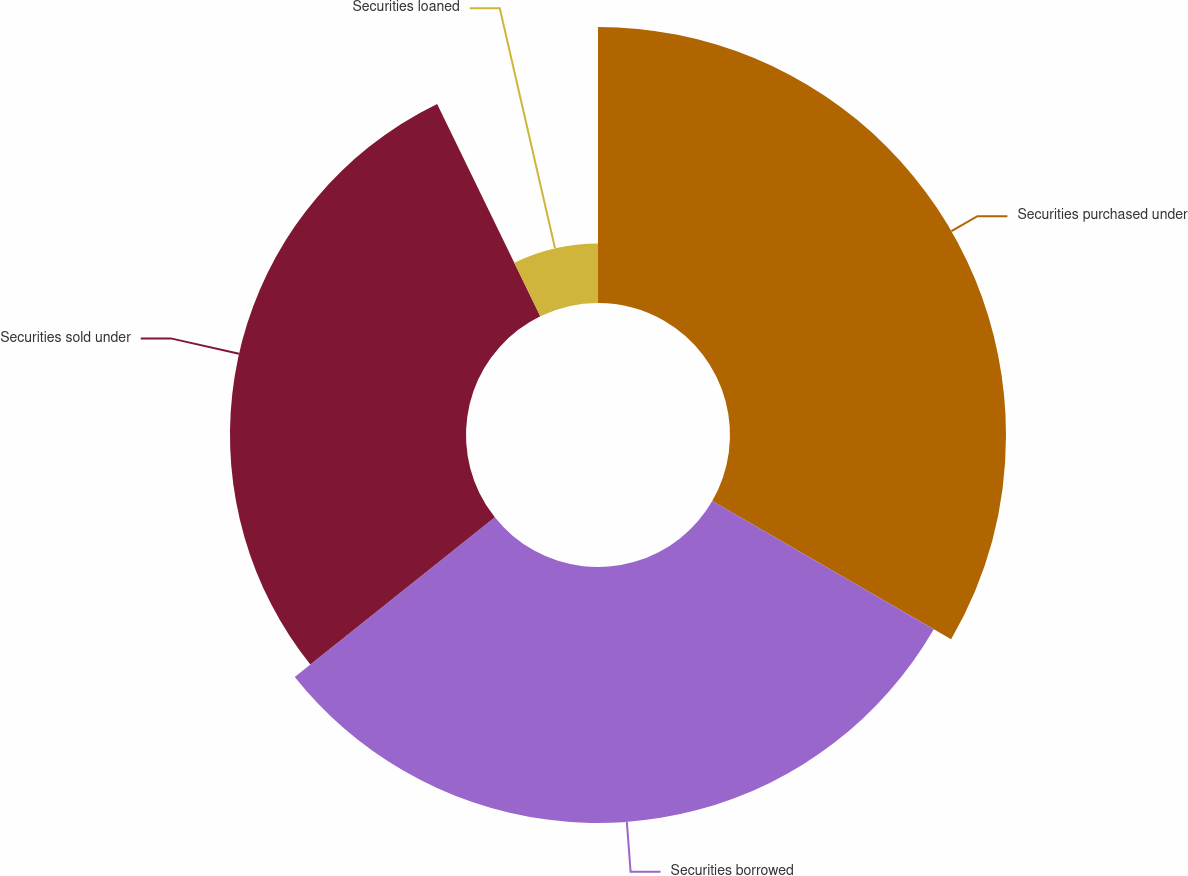Convert chart. <chart><loc_0><loc_0><loc_500><loc_500><pie_chart><fcel>Securities purchased under<fcel>Securities borrowed<fcel>Securities sold under<fcel>Securities loaned<nl><fcel>33.35%<fcel>30.93%<fcel>28.52%<fcel>7.2%<nl></chart> 